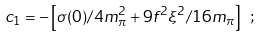Convert formula to latex. <formula><loc_0><loc_0><loc_500><loc_500>c _ { 1 } = - \left [ \sigma ( 0 ) / 4 m _ { \pi } ^ { 2 } + 9 f ^ { 2 } \xi ^ { 2 } / 1 6 m _ { \pi } \right ] \ ;</formula> 